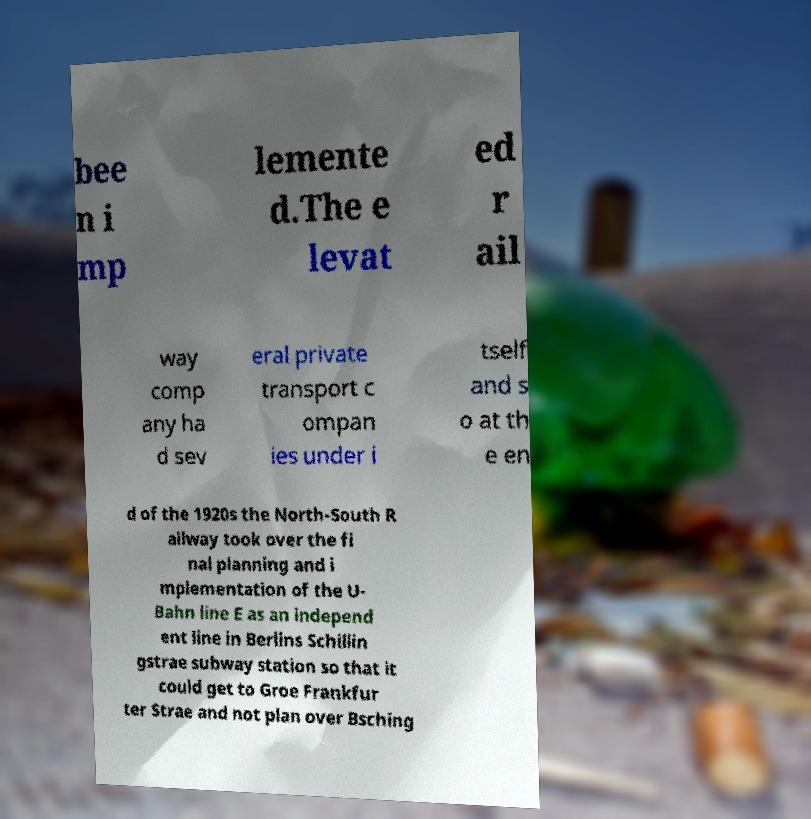For documentation purposes, I need the text within this image transcribed. Could you provide that? bee n i mp lemente d.The e levat ed r ail way comp any ha d sev eral private transport c ompan ies under i tself and s o at th e en d of the 1920s the North-South R ailway took over the fi nal planning and i mplementation of the U- Bahn line E as an independ ent line in Berlins Schillin gstrae subway station so that it could get to Groe Frankfur ter Strae and not plan over Bsching 